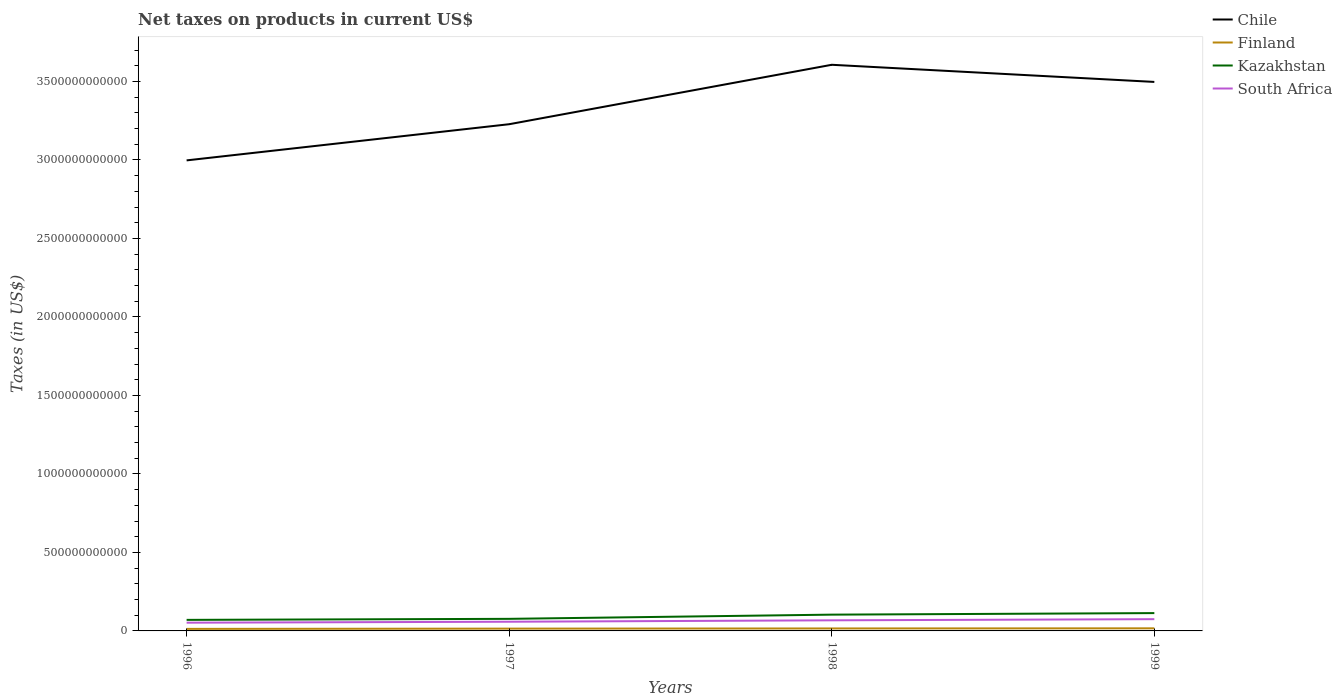How many different coloured lines are there?
Ensure brevity in your answer.  4. Across all years, what is the maximum net taxes on products in Finland?
Give a very brief answer. 1.29e+1. In which year was the net taxes on products in Kazakhstan maximum?
Ensure brevity in your answer.  1996. What is the total net taxes on products in Chile in the graph?
Provide a succinct answer. 1.09e+11. What is the difference between the highest and the second highest net taxes on products in Finland?
Your answer should be compact. 3.60e+09. What is the difference between the highest and the lowest net taxes on products in South Africa?
Offer a very short reply. 2. What is the difference between two consecutive major ticks on the Y-axis?
Your response must be concise. 5.00e+11. How many legend labels are there?
Provide a succinct answer. 4. What is the title of the graph?
Keep it short and to the point. Net taxes on products in current US$. What is the label or title of the X-axis?
Make the answer very short. Years. What is the label or title of the Y-axis?
Offer a very short reply. Taxes (in US$). What is the Taxes (in US$) in Chile in 1996?
Make the answer very short. 3.00e+12. What is the Taxes (in US$) of Finland in 1996?
Give a very brief answer. 1.29e+1. What is the Taxes (in US$) of Kazakhstan in 1996?
Your answer should be compact. 7.04e+1. What is the Taxes (in US$) of South Africa in 1996?
Your answer should be compact. 5.25e+1. What is the Taxes (in US$) in Chile in 1997?
Make the answer very short. 3.23e+12. What is the Taxes (in US$) of Finland in 1997?
Your answer should be compact. 1.47e+1. What is the Taxes (in US$) in Kazakhstan in 1997?
Your response must be concise. 7.69e+1. What is the Taxes (in US$) of South Africa in 1997?
Make the answer very short. 5.86e+1. What is the Taxes (in US$) of Chile in 1998?
Ensure brevity in your answer.  3.61e+12. What is the Taxes (in US$) in Finland in 1998?
Provide a short and direct response. 1.57e+1. What is the Taxes (in US$) in Kazakhstan in 1998?
Your response must be concise. 1.04e+11. What is the Taxes (in US$) in South Africa in 1998?
Offer a terse response. 6.75e+1. What is the Taxes (in US$) in Chile in 1999?
Your response must be concise. 3.50e+12. What is the Taxes (in US$) in Finland in 1999?
Provide a short and direct response. 1.65e+1. What is the Taxes (in US$) in Kazakhstan in 1999?
Keep it short and to the point. 1.14e+11. What is the Taxes (in US$) in South Africa in 1999?
Your answer should be compact. 7.48e+1. Across all years, what is the maximum Taxes (in US$) in Chile?
Offer a very short reply. 3.61e+12. Across all years, what is the maximum Taxes (in US$) of Finland?
Ensure brevity in your answer.  1.65e+1. Across all years, what is the maximum Taxes (in US$) of Kazakhstan?
Make the answer very short. 1.14e+11. Across all years, what is the maximum Taxes (in US$) of South Africa?
Provide a succinct answer. 7.48e+1. Across all years, what is the minimum Taxes (in US$) in Chile?
Ensure brevity in your answer.  3.00e+12. Across all years, what is the minimum Taxes (in US$) of Finland?
Offer a terse response. 1.29e+1. Across all years, what is the minimum Taxes (in US$) of Kazakhstan?
Make the answer very short. 7.04e+1. Across all years, what is the minimum Taxes (in US$) in South Africa?
Your response must be concise. 5.25e+1. What is the total Taxes (in US$) of Chile in the graph?
Offer a very short reply. 1.33e+13. What is the total Taxes (in US$) of Finland in the graph?
Give a very brief answer. 5.98e+1. What is the total Taxes (in US$) of Kazakhstan in the graph?
Your answer should be very brief. 3.64e+11. What is the total Taxes (in US$) in South Africa in the graph?
Give a very brief answer. 2.53e+11. What is the difference between the Taxes (in US$) of Chile in 1996 and that in 1997?
Keep it short and to the point. -2.30e+11. What is the difference between the Taxes (in US$) in Finland in 1996 and that in 1997?
Offer a terse response. -1.78e+09. What is the difference between the Taxes (in US$) in Kazakhstan in 1996 and that in 1997?
Your answer should be compact. -6.48e+09. What is the difference between the Taxes (in US$) in South Africa in 1996 and that in 1997?
Your answer should be compact. -6.08e+09. What is the difference between the Taxes (in US$) of Chile in 1996 and that in 1998?
Keep it short and to the point. -6.09e+11. What is the difference between the Taxes (in US$) of Finland in 1996 and that in 1998?
Provide a short and direct response. -2.81e+09. What is the difference between the Taxes (in US$) of Kazakhstan in 1996 and that in 1998?
Your answer should be compact. -3.33e+1. What is the difference between the Taxes (in US$) in South Africa in 1996 and that in 1998?
Provide a short and direct response. -1.51e+1. What is the difference between the Taxes (in US$) of Chile in 1996 and that in 1999?
Give a very brief answer. -5.00e+11. What is the difference between the Taxes (in US$) of Finland in 1996 and that in 1999?
Offer a terse response. -3.60e+09. What is the difference between the Taxes (in US$) in Kazakhstan in 1996 and that in 1999?
Your response must be concise. -4.31e+1. What is the difference between the Taxes (in US$) of South Africa in 1996 and that in 1999?
Provide a short and direct response. -2.23e+1. What is the difference between the Taxes (in US$) in Chile in 1997 and that in 1998?
Make the answer very short. -3.79e+11. What is the difference between the Taxes (in US$) in Finland in 1997 and that in 1998?
Ensure brevity in your answer.  -1.03e+09. What is the difference between the Taxes (in US$) in Kazakhstan in 1997 and that in 1998?
Ensure brevity in your answer.  -2.68e+1. What is the difference between the Taxes (in US$) of South Africa in 1997 and that in 1998?
Your answer should be compact. -8.99e+09. What is the difference between the Taxes (in US$) of Chile in 1997 and that in 1999?
Keep it short and to the point. -2.69e+11. What is the difference between the Taxes (in US$) in Finland in 1997 and that in 1999?
Offer a terse response. -1.81e+09. What is the difference between the Taxes (in US$) of Kazakhstan in 1997 and that in 1999?
Make the answer very short. -3.66e+1. What is the difference between the Taxes (in US$) of South Africa in 1997 and that in 1999?
Ensure brevity in your answer.  -1.62e+1. What is the difference between the Taxes (in US$) in Chile in 1998 and that in 1999?
Give a very brief answer. 1.09e+11. What is the difference between the Taxes (in US$) of Finland in 1998 and that in 1999?
Keep it short and to the point. -7.85e+08. What is the difference between the Taxes (in US$) in Kazakhstan in 1998 and that in 1999?
Keep it short and to the point. -9.86e+09. What is the difference between the Taxes (in US$) in South Africa in 1998 and that in 1999?
Keep it short and to the point. -7.26e+09. What is the difference between the Taxes (in US$) of Chile in 1996 and the Taxes (in US$) of Finland in 1997?
Make the answer very short. 2.98e+12. What is the difference between the Taxes (in US$) in Chile in 1996 and the Taxes (in US$) in Kazakhstan in 1997?
Provide a short and direct response. 2.92e+12. What is the difference between the Taxes (in US$) in Chile in 1996 and the Taxes (in US$) in South Africa in 1997?
Offer a terse response. 2.94e+12. What is the difference between the Taxes (in US$) in Finland in 1996 and the Taxes (in US$) in Kazakhstan in 1997?
Offer a very short reply. -6.40e+1. What is the difference between the Taxes (in US$) in Finland in 1996 and the Taxes (in US$) in South Africa in 1997?
Make the answer very short. -4.57e+1. What is the difference between the Taxes (in US$) of Kazakhstan in 1996 and the Taxes (in US$) of South Africa in 1997?
Offer a terse response. 1.18e+1. What is the difference between the Taxes (in US$) of Chile in 1996 and the Taxes (in US$) of Finland in 1998?
Provide a short and direct response. 2.98e+12. What is the difference between the Taxes (in US$) of Chile in 1996 and the Taxes (in US$) of Kazakhstan in 1998?
Your answer should be compact. 2.89e+12. What is the difference between the Taxes (in US$) of Chile in 1996 and the Taxes (in US$) of South Africa in 1998?
Ensure brevity in your answer.  2.93e+12. What is the difference between the Taxes (in US$) of Finland in 1996 and the Taxes (in US$) of Kazakhstan in 1998?
Your answer should be compact. -9.08e+1. What is the difference between the Taxes (in US$) of Finland in 1996 and the Taxes (in US$) of South Africa in 1998?
Make the answer very short. -5.47e+1. What is the difference between the Taxes (in US$) in Kazakhstan in 1996 and the Taxes (in US$) in South Africa in 1998?
Provide a short and direct response. 2.86e+09. What is the difference between the Taxes (in US$) of Chile in 1996 and the Taxes (in US$) of Finland in 1999?
Your answer should be compact. 2.98e+12. What is the difference between the Taxes (in US$) of Chile in 1996 and the Taxes (in US$) of Kazakhstan in 1999?
Offer a very short reply. 2.88e+12. What is the difference between the Taxes (in US$) in Chile in 1996 and the Taxes (in US$) in South Africa in 1999?
Your answer should be very brief. 2.92e+12. What is the difference between the Taxes (in US$) in Finland in 1996 and the Taxes (in US$) in Kazakhstan in 1999?
Offer a very short reply. -1.01e+11. What is the difference between the Taxes (in US$) in Finland in 1996 and the Taxes (in US$) in South Africa in 1999?
Offer a very short reply. -6.19e+1. What is the difference between the Taxes (in US$) of Kazakhstan in 1996 and the Taxes (in US$) of South Africa in 1999?
Give a very brief answer. -4.40e+09. What is the difference between the Taxes (in US$) in Chile in 1997 and the Taxes (in US$) in Finland in 1998?
Ensure brevity in your answer.  3.21e+12. What is the difference between the Taxes (in US$) of Chile in 1997 and the Taxes (in US$) of Kazakhstan in 1998?
Ensure brevity in your answer.  3.12e+12. What is the difference between the Taxes (in US$) of Chile in 1997 and the Taxes (in US$) of South Africa in 1998?
Offer a very short reply. 3.16e+12. What is the difference between the Taxes (in US$) of Finland in 1997 and the Taxes (in US$) of Kazakhstan in 1998?
Offer a very short reply. -8.90e+1. What is the difference between the Taxes (in US$) of Finland in 1997 and the Taxes (in US$) of South Africa in 1998?
Make the answer very short. -5.29e+1. What is the difference between the Taxes (in US$) of Kazakhstan in 1997 and the Taxes (in US$) of South Africa in 1998?
Make the answer very short. 9.34e+09. What is the difference between the Taxes (in US$) of Chile in 1997 and the Taxes (in US$) of Finland in 1999?
Provide a short and direct response. 3.21e+12. What is the difference between the Taxes (in US$) in Chile in 1997 and the Taxes (in US$) in Kazakhstan in 1999?
Keep it short and to the point. 3.11e+12. What is the difference between the Taxes (in US$) of Chile in 1997 and the Taxes (in US$) of South Africa in 1999?
Make the answer very short. 3.15e+12. What is the difference between the Taxes (in US$) of Finland in 1997 and the Taxes (in US$) of Kazakhstan in 1999?
Provide a short and direct response. -9.89e+1. What is the difference between the Taxes (in US$) of Finland in 1997 and the Taxes (in US$) of South Africa in 1999?
Give a very brief answer. -6.01e+1. What is the difference between the Taxes (in US$) in Kazakhstan in 1997 and the Taxes (in US$) in South Africa in 1999?
Make the answer very short. 2.08e+09. What is the difference between the Taxes (in US$) of Chile in 1998 and the Taxes (in US$) of Finland in 1999?
Ensure brevity in your answer.  3.59e+12. What is the difference between the Taxes (in US$) of Chile in 1998 and the Taxes (in US$) of Kazakhstan in 1999?
Your answer should be compact. 3.49e+12. What is the difference between the Taxes (in US$) in Chile in 1998 and the Taxes (in US$) in South Africa in 1999?
Make the answer very short. 3.53e+12. What is the difference between the Taxes (in US$) in Finland in 1998 and the Taxes (in US$) in Kazakhstan in 1999?
Give a very brief answer. -9.78e+1. What is the difference between the Taxes (in US$) of Finland in 1998 and the Taxes (in US$) of South Africa in 1999?
Give a very brief answer. -5.91e+1. What is the difference between the Taxes (in US$) of Kazakhstan in 1998 and the Taxes (in US$) of South Africa in 1999?
Your answer should be very brief. 2.89e+1. What is the average Taxes (in US$) in Chile per year?
Your answer should be very brief. 3.33e+12. What is the average Taxes (in US$) in Finland per year?
Keep it short and to the point. 1.49e+1. What is the average Taxes (in US$) in Kazakhstan per year?
Offer a terse response. 9.11e+1. What is the average Taxes (in US$) in South Africa per year?
Provide a succinct answer. 6.34e+1. In the year 1996, what is the difference between the Taxes (in US$) in Chile and Taxes (in US$) in Finland?
Keep it short and to the point. 2.98e+12. In the year 1996, what is the difference between the Taxes (in US$) in Chile and Taxes (in US$) in Kazakhstan?
Your response must be concise. 2.93e+12. In the year 1996, what is the difference between the Taxes (in US$) of Chile and Taxes (in US$) of South Africa?
Keep it short and to the point. 2.94e+12. In the year 1996, what is the difference between the Taxes (in US$) in Finland and Taxes (in US$) in Kazakhstan?
Provide a succinct answer. -5.75e+1. In the year 1996, what is the difference between the Taxes (in US$) of Finland and Taxes (in US$) of South Africa?
Your answer should be very brief. -3.96e+1. In the year 1996, what is the difference between the Taxes (in US$) of Kazakhstan and Taxes (in US$) of South Africa?
Give a very brief answer. 1.79e+1. In the year 1997, what is the difference between the Taxes (in US$) of Chile and Taxes (in US$) of Finland?
Make the answer very short. 3.21e+12. In the year 1997, what is the difference between the Taxes (in US$) in Chile and Taxes (in US$) in Kazakhstan?
Ensure brevity in your answer.  3.15e+12. In the year 1997, what is the difference between the Taxes (in US$) in Chile and Taxes (in US$) in South Africa?
Provide a short and direct response. 3.17e+12. In the year 1997, what is the difference between the Taxes (in US$) of Finland and Taxes (in US$) of Kazakhstan?
Keep it short and to the point. -6.22e+1. In the year 1997, what is the difference between the Taxes (in US$) in Finland and Taxes (in US$) in South Africa?
Your answer should be compact. -4.39e+1. In the year 1997, what is the difference between the Taxes (in US$) in Kazakhstan and Taxes (in US$) in South Africa?
Your answer should be very brief. 1.83e+1. In the year 1998, what is the difference between the Taxes (in US$) of Chile and Taxes (in US$) of Finland?
Your answer should be compact. 3.59e+12. In the year 1998, what is the difference between the Taxes (in US$) of Chile and Taxes (in US$) of Kazakhstan?
Make the answer very short. 3.50e+12. In the year 1998, what is the difference between the Taxes (in US$) of Chile and Taxes (in US$) of South Africa?
Make the answer very short. 3.54e+12. In the year 1998, what is the difference between the Taxes (in US$) in Finland and Taxes (in US$) in Kazakhstan?
Your response must be concise. -8.80e+1. In the year 1998, what is the difference between the Taxes (in US$) in Finland and Taxes (in US$) in South Africa?
Your answer should be very brief. -5.18e+1. In the year 1998, what is the difference between the Taxes (in US$) in Kazakhstan and Taxes (in US$) in South Africa?
Keep it short and to the point. 3.61e+1. In the year 1999, what is the difference between the Taxes (in US$) of Chile and Taxes (in US$) of Finland?
Make the answer very short. 3.48e+12. In the year 1999, what is the difference between the Taxes (in US$) of Chile and Taxes (in US$) of Kazakhstan?
Provide a short and direct response. 3.38e+12. In the year 1999, what is the difference between the Taxes (in US$) in Chile and Taxes (in US$) in South Africa?
Offer a terse response. 3.42e+12. In the year 1999, what is the difference between the Taxes (in US$) of Finland and Taxes (in US$) of Kazakhstan?
Provide a short and direct response. -9.70e+1. In the year 1999, what is the difference between the Taxes (in US$) of Finland and Taxes (in US$) of South Africa?
Ensure brevity in your answer.  -5.83e+1. In the year 1999, what is the difference between the Taxes (in US$) in Kazakhstan and Taxes (in US$) in South Africa?
Provide a short and direct response. 3.87e+1. What is the ratio of the Taxes (in US$) in Finland in 1996 to that in 1997?
Make the answer very short. 0.88. What is the ratio of the Taxes (in US$) in Kazakhstan in 1996 to that in 1997?
Offer a very short reply. 0.92. What is the ratio of the Taxes (in US$) in South Africa in 1996 to that in 1997?
Ensure brevity in your answer.  0.9. What is the ratio of the Taxes (in US$) in Chile in 1996 to that in 1998?
Your response must be concise. 0.83. What is the ratio of the Taxes (in US$) in Finland in 1996 to that in 1998?
Offer a terse response. 0.82. What is the ratio of the Taxes (in US$) of Kazakhstan in 1996 to that in 1998?
Give a very brief answer. 0.68. What is the ratio of the Taxes (in US$) of South Africa in 1996 to that in 1998?
Make the answer very short. 0.78. What is the ratio of the Taxes (in US$) of Chile in 1996 to that in 1999?
Provide a succinct answer. 0.86. What is the ratio of the Taxes (in US$) in Finland in 1996 to that in 1999?
Your answer should be very brief. 0.78. What is the ratio of the Taxes (in US$) of Kazakhstan in 1996 to that in 1999?
Give a very brief answer. 0.62. What is the ratio of the Taxes (in US$) in South Africa in 1996 to that in 1999?
Provide a short and direct response. 0.7. What is the ratio of the Taxes (in US$) of Chile in 1997 to that in 1998?
Your answer should be compact. 0.9. What is the ratio of the Taxes (in US$) in Finland in 1997 to that in 1998?
Give a very brief answer. 0.93. What is the ratio of the Taxes (in US$) of Kazakhstan in 1997 to that in 1998?
Offer a terse response. 0.74. What is the ratio of the Taxes (in US$) in South Africa in 1997 to that in 1998?
Offer a terse response. 0.87. What is the ratio of the Taxes (in US$) of Chile in 1997 to that in 1999?
Keep it short and to the point. 0.92. What is the ratio of the Taxes (in US$) in Finland in 1997 to that in 1999?
Keep it short and to the point. 0.89. What is the ratio of the Taxes (in US$) of Kazakhstan in 1997 to that in 1999?
Offer a terse response. 0.68. What is the ratio of the Taxes (in US$) of South Africa in 1997 to that in 1999?
Your response must be concise. 0.78. What is the ratio of the Taxes (in US$) of Chile in 1998 to that in 1999?
Offer a very short reply. 1.03. What is the ratio of the Taxes (in US$) in Kazakhstan in 1998 to that in 1999?
Make the answer very short. 0.91. What is the ratio of the Taxes (in US$) in South Africa in 1998 to that in 1999?
Your response must be concise. 0.9. What is the difference between the highest and the second highest Taxes (in US$) of Chile?
Your answer should be compact. 1.09e+11. What is the difference between the highest and the second highest Taxes (in US$) in Finland?
Keep it short and to the point. 7.85e+08. What is the difference between the highest and the second highest Taxes (in US$) in Kazakhstan?
Your response must be concise. 9.86e+09. What is the difference between the highest and the second highest Taxes (in US$) of South Africa?
Your response must be concise. 7.26e+09. What is the difference between the highest and the lowest Taxes (in US$) in Chile?
Make the answer very short. 6.09e+11. What is the difference between the highest and the lowest Taxes (in US$) of Finland?
Keep it short and to the point. 3.60e+09. What is the difference between the highest and the lowest Taxes (in US$) in Kazakhstan?
Your answer should be very brief. 4.31e+1. What is the difference between the highest and the lowest Taxes (in US$) in South Africa?
Offer a very short reply. 2.23e+1. 